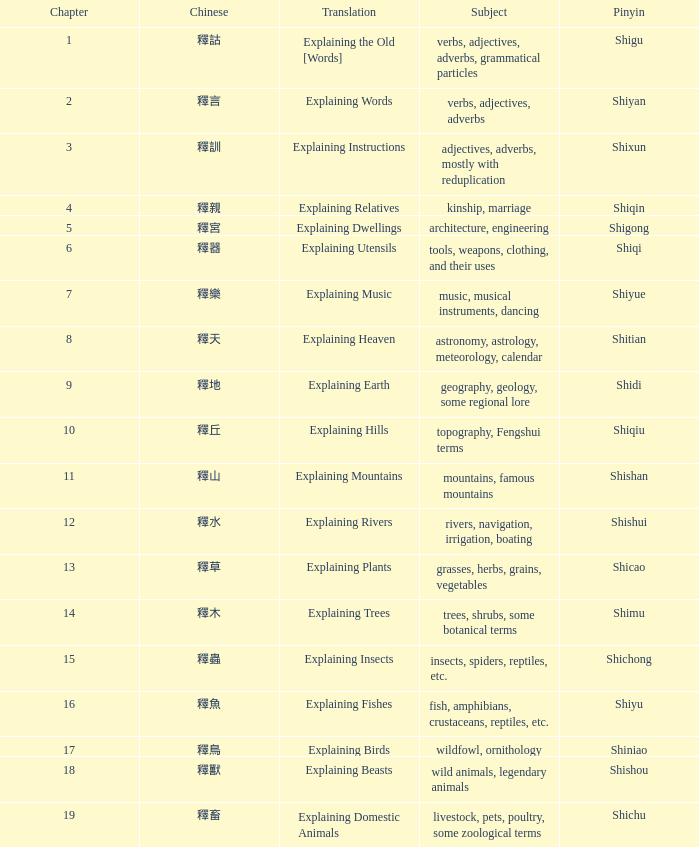Name the chinese with subject of adjectives, adverbs, mostly with reduplication 釋訓. 